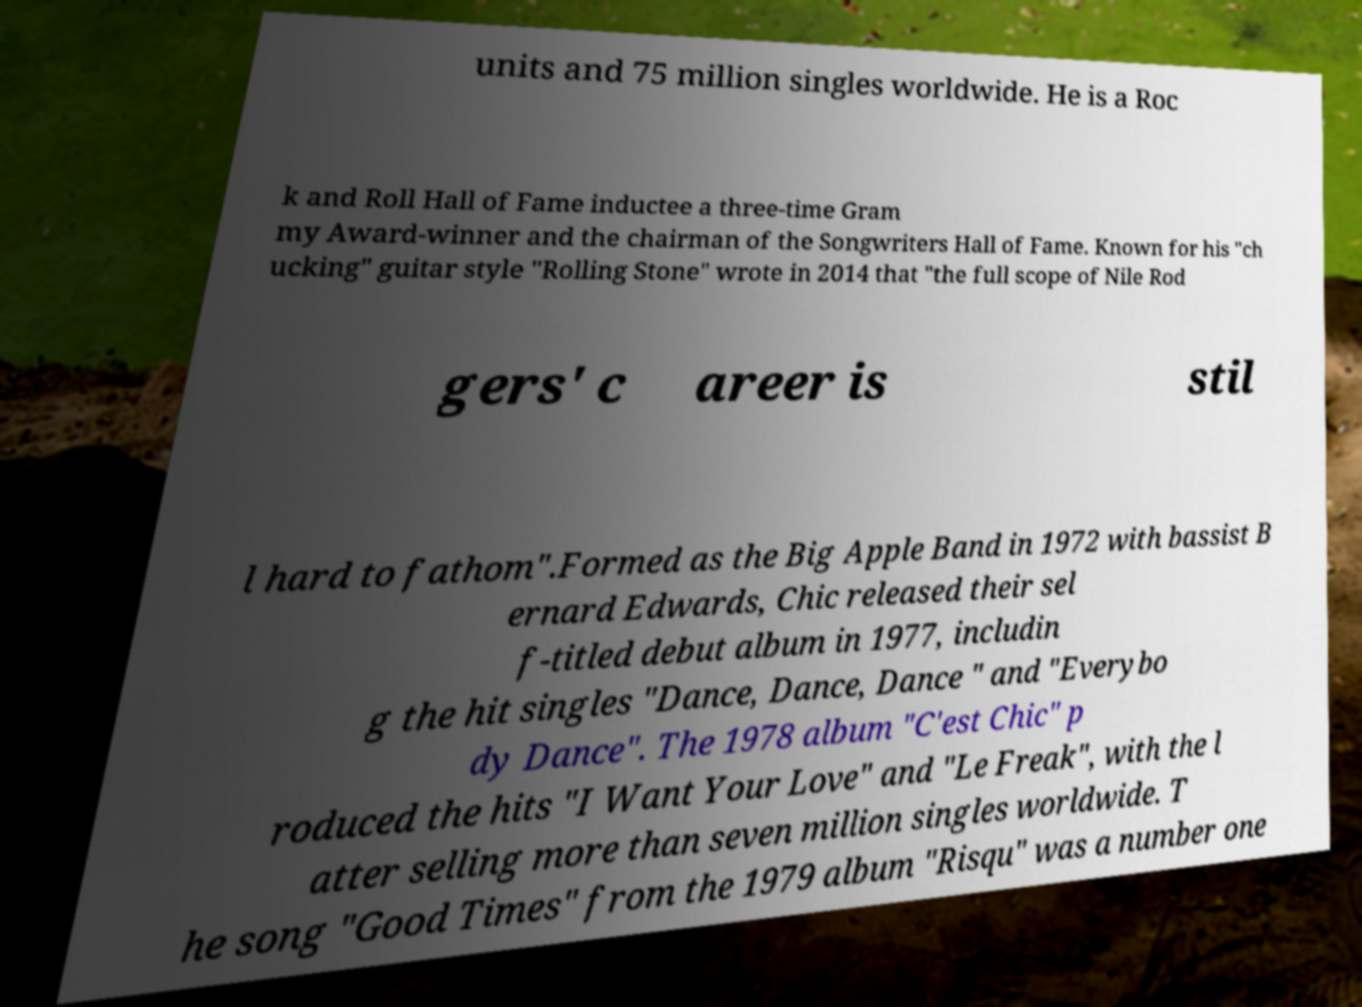Please identify and transcribe the text found in this image. units and 75 million singles worldwide. He is a Roc k and Roll Hall of Fame inductee a three-time Gram my Award-winner and the chairman of the Songwriters Hall of Fame. Known for his "ch ucking" guitar style "Rolling Stone" wrote in 2014 that "the full scope of Nile Rod gers' c areer is stil l hard to fathom".Formed as the Big Apple Band in 1972 with bassist B ernard Edwards, Chic released their sel f-titled debut album in 1977, includin g the hit singles "Dance, Dance, Dance " and "Everybo dy Dance". The 1978 album "C'est Chic" p roduced the hits "I Want Your Love" and "Le Freak", with the l atter selling more than seven million singles worldwide. T he song "Good Times" from the 1979 album "Risqu" was a number one 